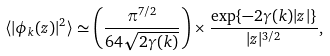Convert formula to latex. <formula><loc_0><loc_0><loc_500><loc_500>\langle | \phi _ { k } ( z ) | ^ { 2 } \rangle \simeq \left ( \frac { \pi ^ { 7 / 2 } } { 6 4 \sqrt { 2 \gamma ( k ) } } \right ) \times \frac { \exp \{ - 2 \gamma ( k ) | z | \} } { | z | ^ { 3 / 2 } } ,</formula> 